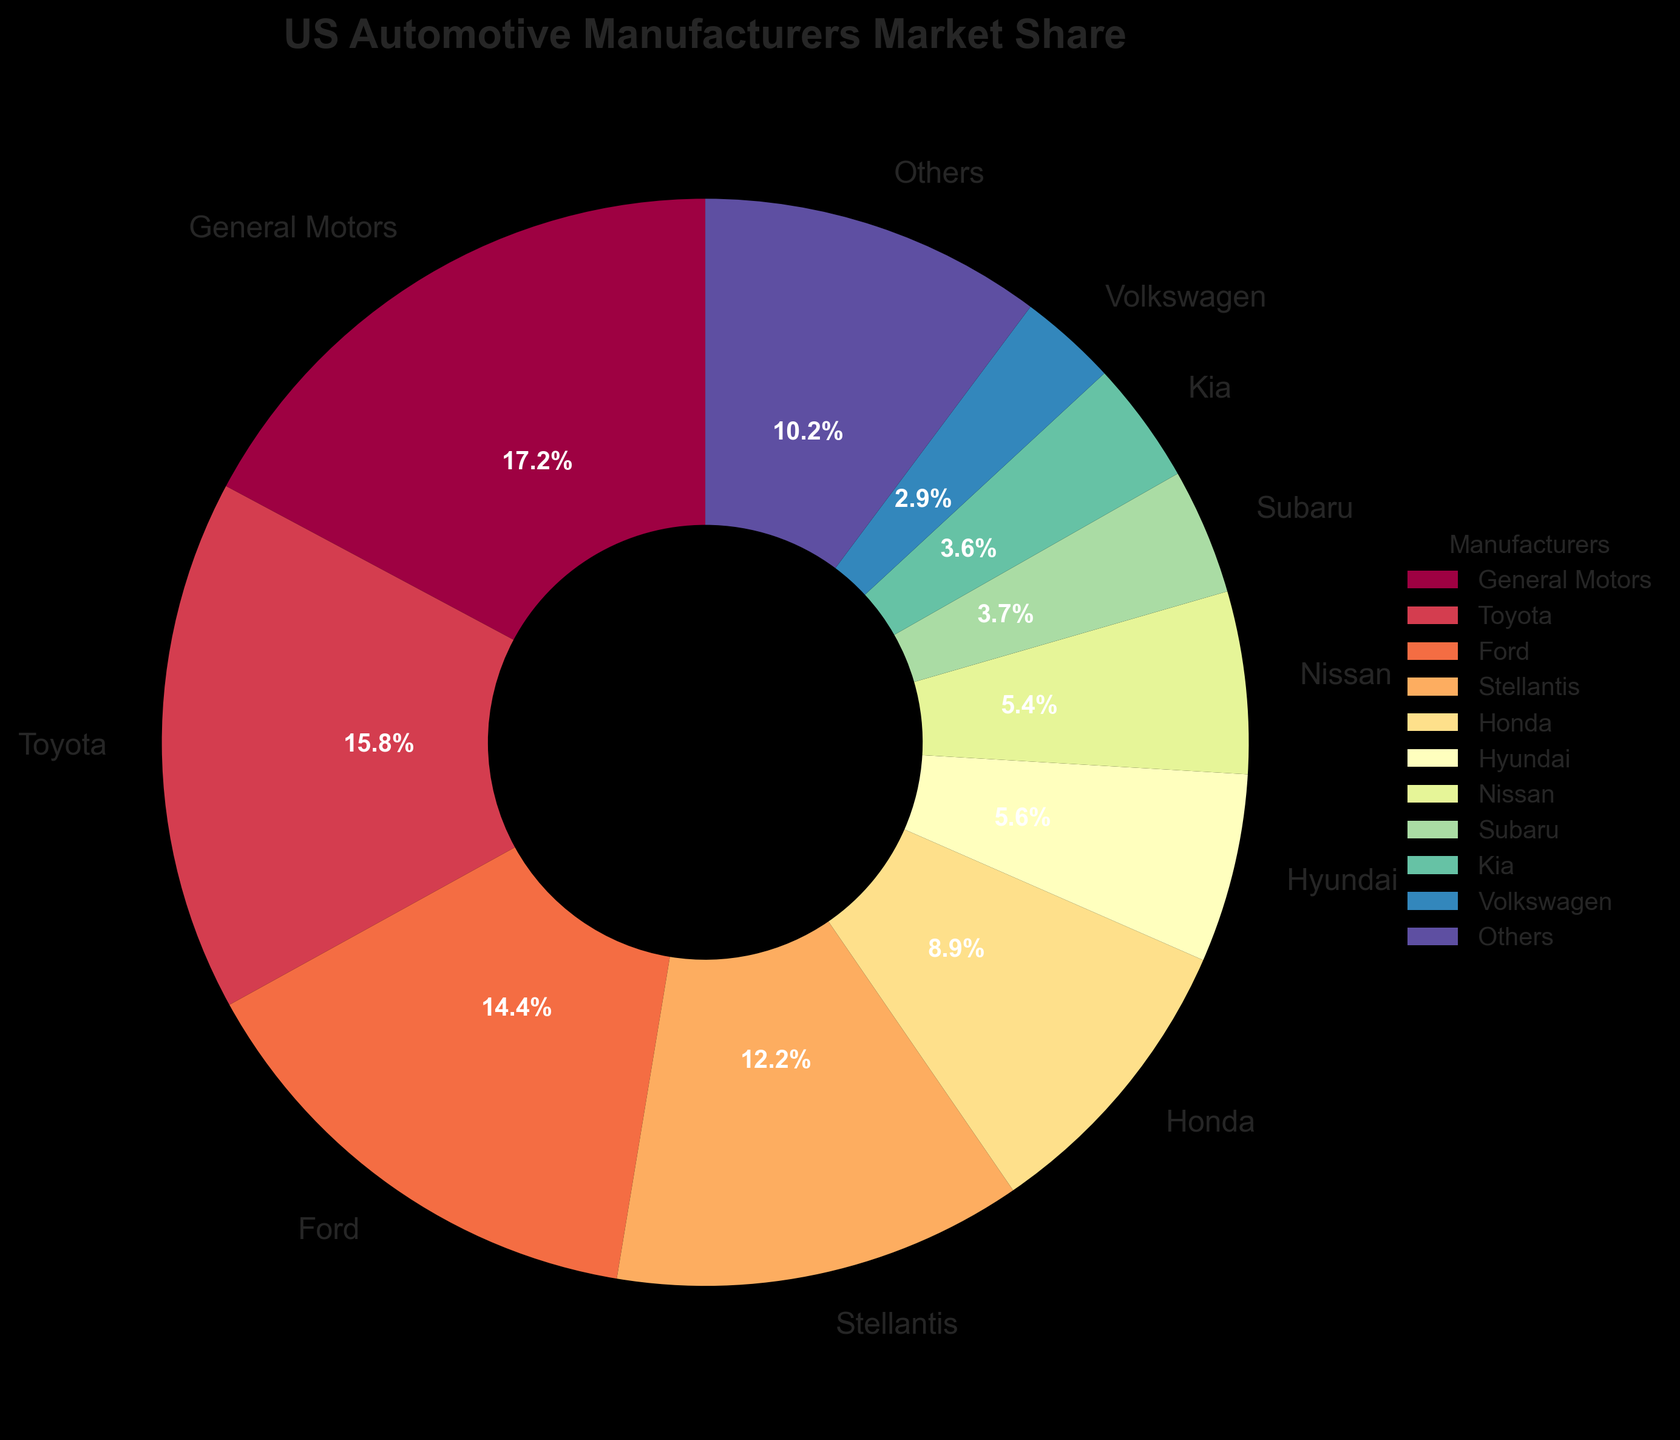Which manufacturer has the highest market share? By looking at the pie chart, we see that General Motors has the largest slice of the pie, indicating that it has the highest market share among the automotive manufacturers listed.
Answer: General Motors What's the combined market share of the top 3 manufacturers? The top 3 manufacturers are General Motors, Toyota, and Ford. Their market shares are 16.5%, 15.2%, and 13.8% respectively. Adding these values together: 16.5 + 15.2 + 13.8 = 45.5%.
Answer: 45.5% Is Toyota's market share greater than Ford and Hyundai combined? Toyota's market share is 15.2%. Ford has 13.8% and Hyundai has 5.4%, so their combined market share is 13.8 + 5.4 = 19.2%. Comparing the two, 15.2% is less than 19.2%.
Answer: No What is the total market share of the smallest 5 manufacturers? The smallest 5 manufacturers are Mitsubishi, Volvo, Tesla, Mazda, and Jaguar Land Rover. Their market shares are 0.7%, 0.9%, 1.8%, 1.9%, and 0.4%, respectively. Adding these values together: 0.7 + 0.9 + 1.8 + 1.9 + 0.4 = 5.7%.
Answer: 5.7% Which manufacturer falls between Nissan and Volkswagen in terms of market share? Looking at the pie chart, we see that Subaru is between Nissan (5.2%) and Volkswagen (2.8%) in terms of market share with 3.6%.
Answer: Subaru What is the difference in market share between Hyundai and Kia? Hyundai has a market share of 5.4% and Kia has 3.5%. The difference is calculated as 5.4 - 3.5 = 1.9%.
Answer: 1.9% Which manufacturer has a market share closest to 2%? From the pie chart, we see that Mercedes-Benz has a market share of 2.0%, which is exactly 2%.
Answer: Mercedes-Benz How many manufacturers have a market share less than 3%? From the pie chart, the manufacturers with a market share less than 3% are Volkswagen, BMW, Mercedes-Benz, Mazda, Tesla, Volvo, Mitsubishi, and Jaguar Land Rover. Counting these, we have 8 manufacturers.
Answer: 8 What's the sum of market shares of Honda and Nissan? Honda has a market share of 8.5% and Nissan has a market share of 5.2%. Adding these together: 8.5 + 5.2 = 13.7%.
Answer: 13.7% 